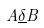Convert formula to latex. <formula><loc_0><loc_0><loc_500><loc_500>A \underline { \delta } B</formula> 